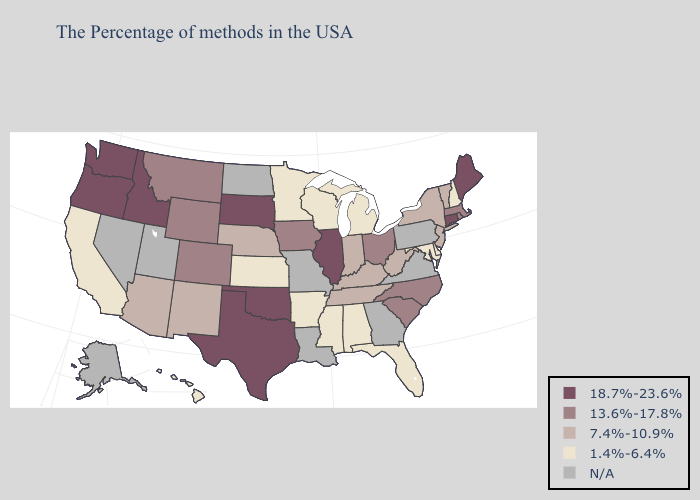Name the states that have a value in the range N/A?
Keep it brief. Pennsylvania, Virginia, Georgia, Louisiana, Missouri, North Dakota, Utah, Nevada, Alaska. What is the value of Wisconsin?
Answer briefly. 1.4%-6.4%. Name the states that have a value in the range N/A?
Answer briefly. Pennsylvania, Virginia, Georgia, Louisiana, Missouri, North Dakota, Utah, Nevada, Alaska. Name the states that have a value in the range 1.4%-6.4%?
Quick response, please. New Hampshire, Delaware, Maryland, Florida, Michigan, Alabama, Wisconsin, Mississippi, Arkansas, Minnesota, Kansas, California, Hawaii. Does Hawaii have the highest value in the West?
Be succinct. No. Is the legend a continuous bar?
Give a very brief answer. No. Does Massachusetts have the highest value in the Northeast?
Answer briefly. No. Does the map have missing data?
Be succinct. Yes. Name the states that have a value in the range 18.7%-23.6%?
Answer briefly. Maine, Connecticut, Illinois, Oklahoma, Texas, South Dakota, Idaho, Washington, Oregon. What is the lowest value in states that border Nebraska?
Concise answer only. 1.4%-6.4%. What is the highest value in the USA?
Concise answer only. 18.7%-23.6%. Does Oklahoma have the lowest value in the USA?
Keep it brief. No. Name the states that have a value in the range 18.7%-23.6%?
Give a very brief answer. Maine, Connecticut, Illinois, Oklahoma, Texas, South Dakota, Idaho, Washington, Oregon. 